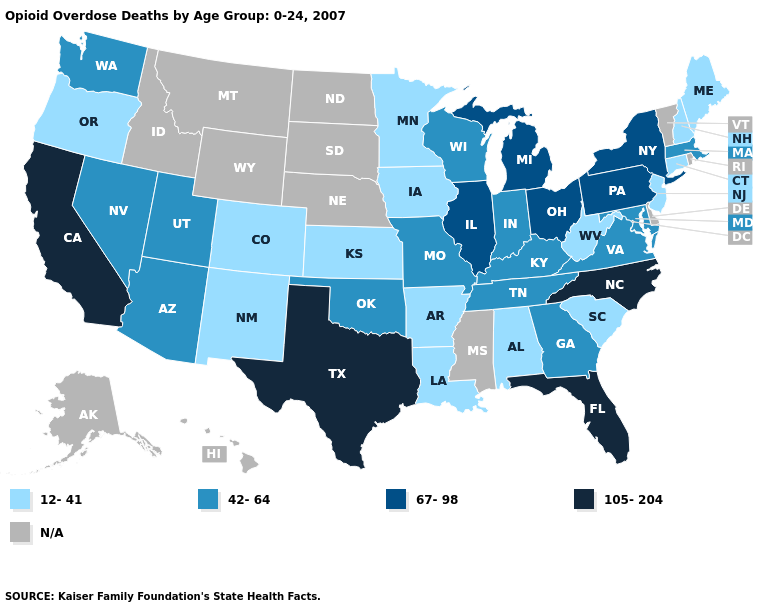What is the value of Kentucky?
Concise answer only. 42-64. Which states have the lowest value in the West?
Write a very short answer. Colorado, New Mexico, Oregon. Name the states that have a value in the range N/A?
Give a very brief answer. Alaska, Delaware, Hawaii, Idaho, Mississippi, Montana, Nebraska, North Dakota, Rhode Island, South Dakota, Vermont, Wyoming. Among the states that border Iowa , does Minnesota have the lowest value?
Write a very short answer. Yes. Which states have the lowest value in the USA?
Quick response, please. Alabama, Arkansas, Colorado, Connecticut, Iowa, Kansas, Louisiana, Maine, Minnesota, New Hampshire, New Jersey, New Mexico, Oregon, South Carolina, West Virginia. Which states have the highest value in the USA?
Quick response, please. California, Florida, North Carolina, Texas. Does Illinois have the lowest value in the MidWest?
Keep it brief. No. What is the value of Alaska?
Be succinct. N/A. Does Utah have the lowest value in the West?
Short answer required. No. Which states have the highest value in the USA?
Keep it brief. California, Florida, North Carolina, Texas. Among the states that border Kentucky , does Ohio have the highest value?
Answer briefly. Yes. Which states hav the highest value in the Northeast?
Short answer required. New York, Pennsylvania. Which states have the lowest value in the South?
Answer briefly. Alabama, Arkansas, Louisiana, South Carolina, West Virginia. What is the value of Alaska?
Write a very short answer. N/A. 